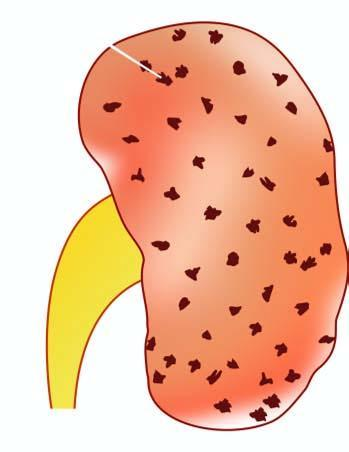does the silicotic nodule show characteristic 'flea bitten kidney ' due to tiny petechial haemorrhages on the surface?
Answer the question using a single word or phrase. No 